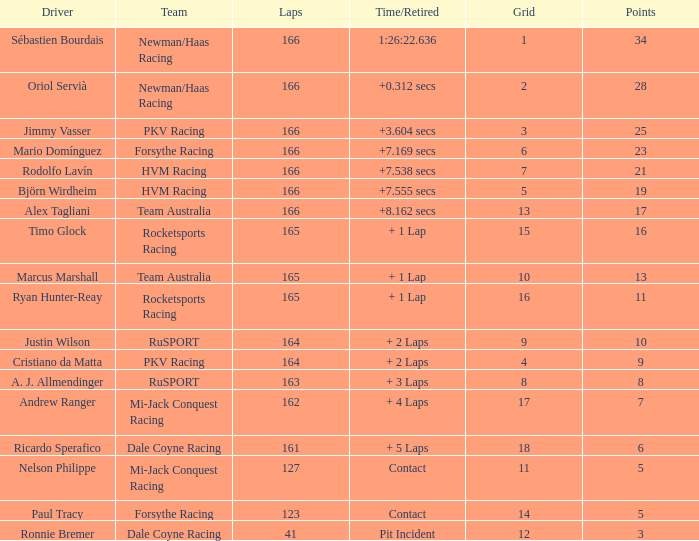What is the name of the operator with 6 points? Ricardo Sperafico. 